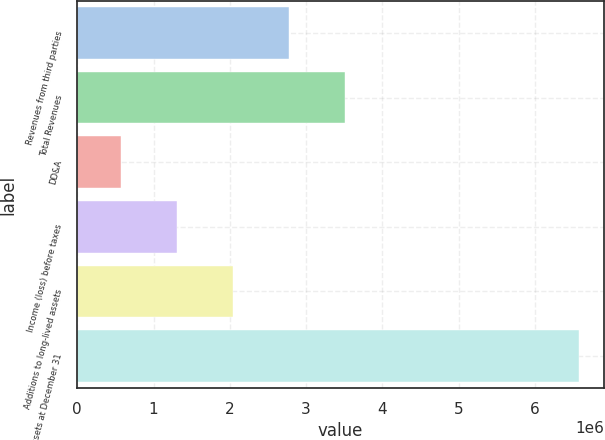<chart> <loc_0><loc_0><loc_500><loc_500><bar_chart><fcel>Revenues from third parties<fcel>Total Revenues<fcel>DD&A<fcel>Income (loss) before taxes<fcel>Additions to long-lived assets<fcel>Total assets at December 31<nl><fcel>2.77713e+06<fcel>3.51151e+06<fcel>574001<fcel>1.30838e+06<fcel>2.04276e+06<fcel>6.57785e+06<nl></chart> 